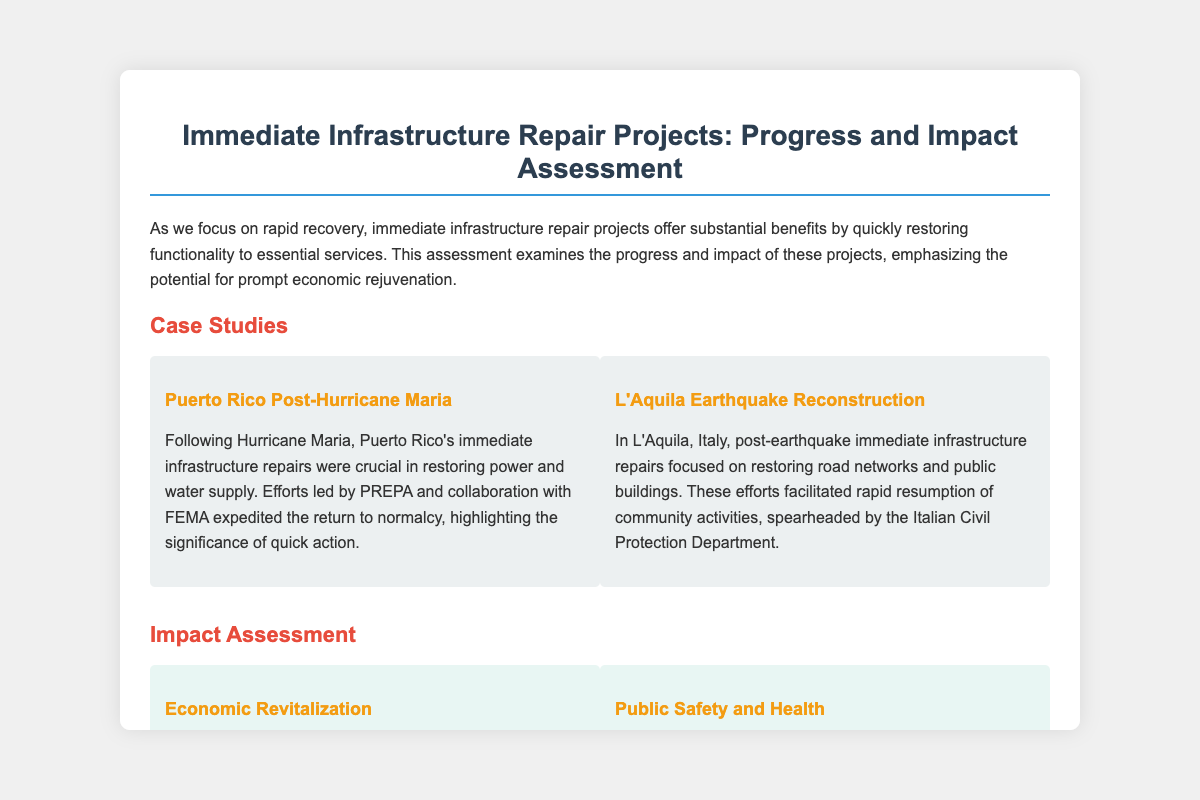What is the title of the presentation? The title of the presentation is mentioned at the top of the document to summarize the topic discussed.
Answer: Immediate Infrastructure Repair Projects: Progress and Impact Assessment Which case study focuses on Hurricane Maria? The case studies section includes specific examples of infrastructure repair efforts following significant events, including Hurricane Maria.
Answer: Puerto Rico Post-Hurricane Maria What was a primary focus of the L'Aquila case study? The focus of the L'Aquila case study is identified through the description of the efforts made to restore certain types of infrastructure.
Answer: Restoring road networks and public buildings What type of impact is highlighted under Economic Revitalization? The document specifies the broader effect of infrastructure repair on local economies by identifying potential outcomes from these activities.
Answer: Minimize economic downtime What is identified as a critical step in Flint, Michigan? This critical step is highlighted to show a response to specific infrastructure needs in the context of public health and safety.
Answer: Rapid pipeline replacements What challenge is mentioned regarding repair projects? The challenges section lists various issues that can arise, which impede the progress and efficiency of infrastructure repairs.
Answer: Logistical Hurdles What conclusion is drawn about immediate repair projects? The conclusion reiterates the overall view on the role these projects play in recovery, summarizing their importance to communities.
Answer: Serve as the backbone of disaster recovery What do policymakers need to balance according to the document? This question emphasizes the need for a strategic approach to ensure comprehensive planning and execution in projects.
Answer: Immediate and long-term needs 